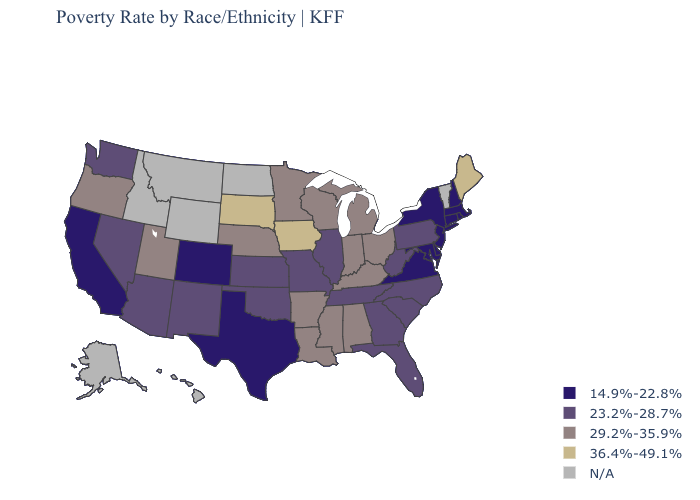Name the states that have a value in the range 29.2%-35.9%?
Be succinct. Alabama, Arkansas, Indiana, Kentucky, Louisiana, Michigan, Minnesota, Mississippi, Nebraska, Ohio, Oregon, Utah, Wisconsin. Name the states that have a value in the range N/A?
Quick response, please. Alaska, Hawaii, Idaho, Montana, North Dakota, Vermont, Wyoming. What is the highest value in states that border New Mexico?
Be succinct. 29.2%-35.9%. Name the states that have a value in the range 29.2%-35.9%?
Give a very brief answer. Alabama, Arkansas, Indiana, Kentucky, Louisiana, Michigan, Minnesota, Mississippi, Nebraska, Ohio, Oregon, Utah, Wisconsin. Which states have the lowest value in the USA?
Quick response, please. California, Colorado, Connecticut, Delaware, Maryland, Massachusetts, New Hampshire, New Jersey, New York, Rhode Island, Texas, Virginia. Among the states that border Connecticut , which have the lowest value?
Answer briefly. Massachusetts, New York, Rhode Island. What is the highest value in the USA?
Answer briefly. 36.4%-49.1%. What is the value of North Carolina?
Concise answer only. 23.2%-28.7%. Which states have the lowest value in the Northeast?
Be succinct. Connecticut, Massachusetts, New Hampshire, New Jersey, New York, Rhode Island. Which states have the lowest value in the USA?
Be succinct. California, Colorado, Connecticut, Delaware, Maryland, Massachusetts, New Hampshire, New Jersey, New York, Rhode Island, Texas, Virginia. Name the states that have a value in the range 29.2%-35.9%?
Quick response, please. Alabama, Arkansas, Indiana, Kentucky, Louisiana, Michigan, Minnesota, Mississippi, Nebraska, Ohio, Oregon, Utah, Wisconsin. What is the value of Oklahoma?
Give a very brief answer. 23.2%-28.7%. What is the value of Ohio?
Write a very short answer. 29.2%-35.9%. Name the states that have a value in the range 23.2%-28.7%?
Keep it brief. Arizona, Florida, Georgia, Illinois, Kansas, Missouri, Nevada, New Mexico, North Carolina, Oklahoma, Pennsylvania, South Carolina, Tennessee, Washington, West Virginia. What is the value of Kentucky?
Give a very brief answer. 29.2%-35.9%. 